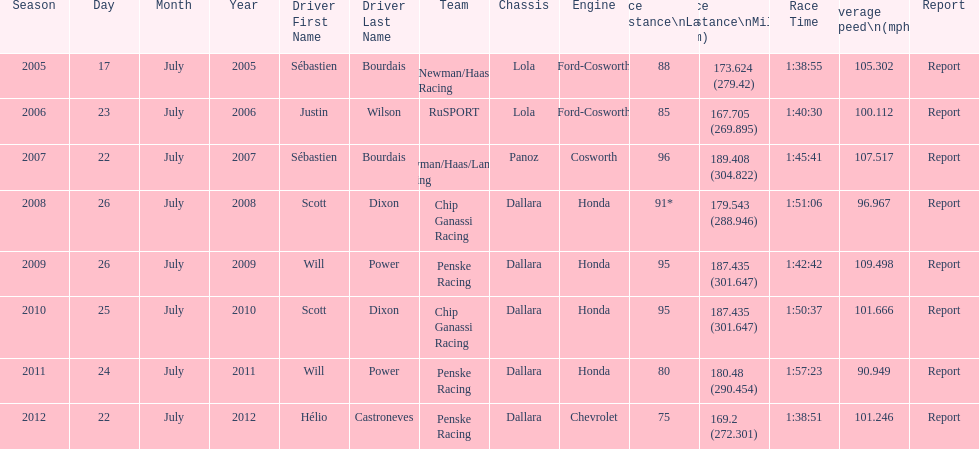How many different teams are represented in the table? 4. 